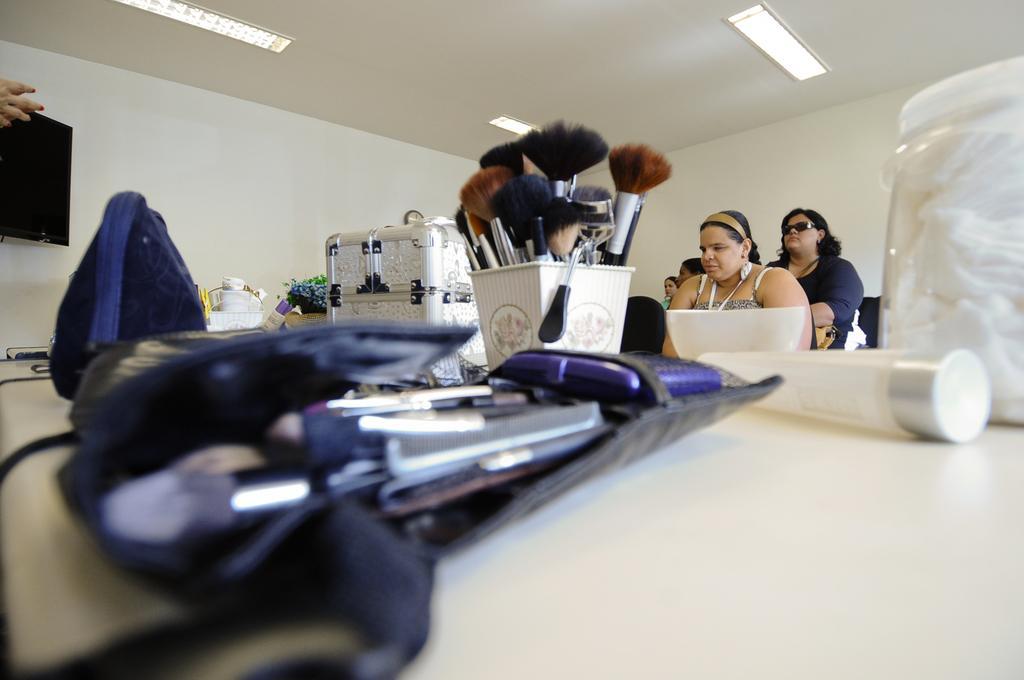Could you give a brief overview of what you see in this image? There are few people sitting. These are the makeup brushes, which are kept in a stand. I can see few cosmetics, makeup brushes, bowl, box and few other things are placed on the table. These are the ceiling lights, which are at the top. On the left side of the image, that looks like a screen, which is attached to the wall. 